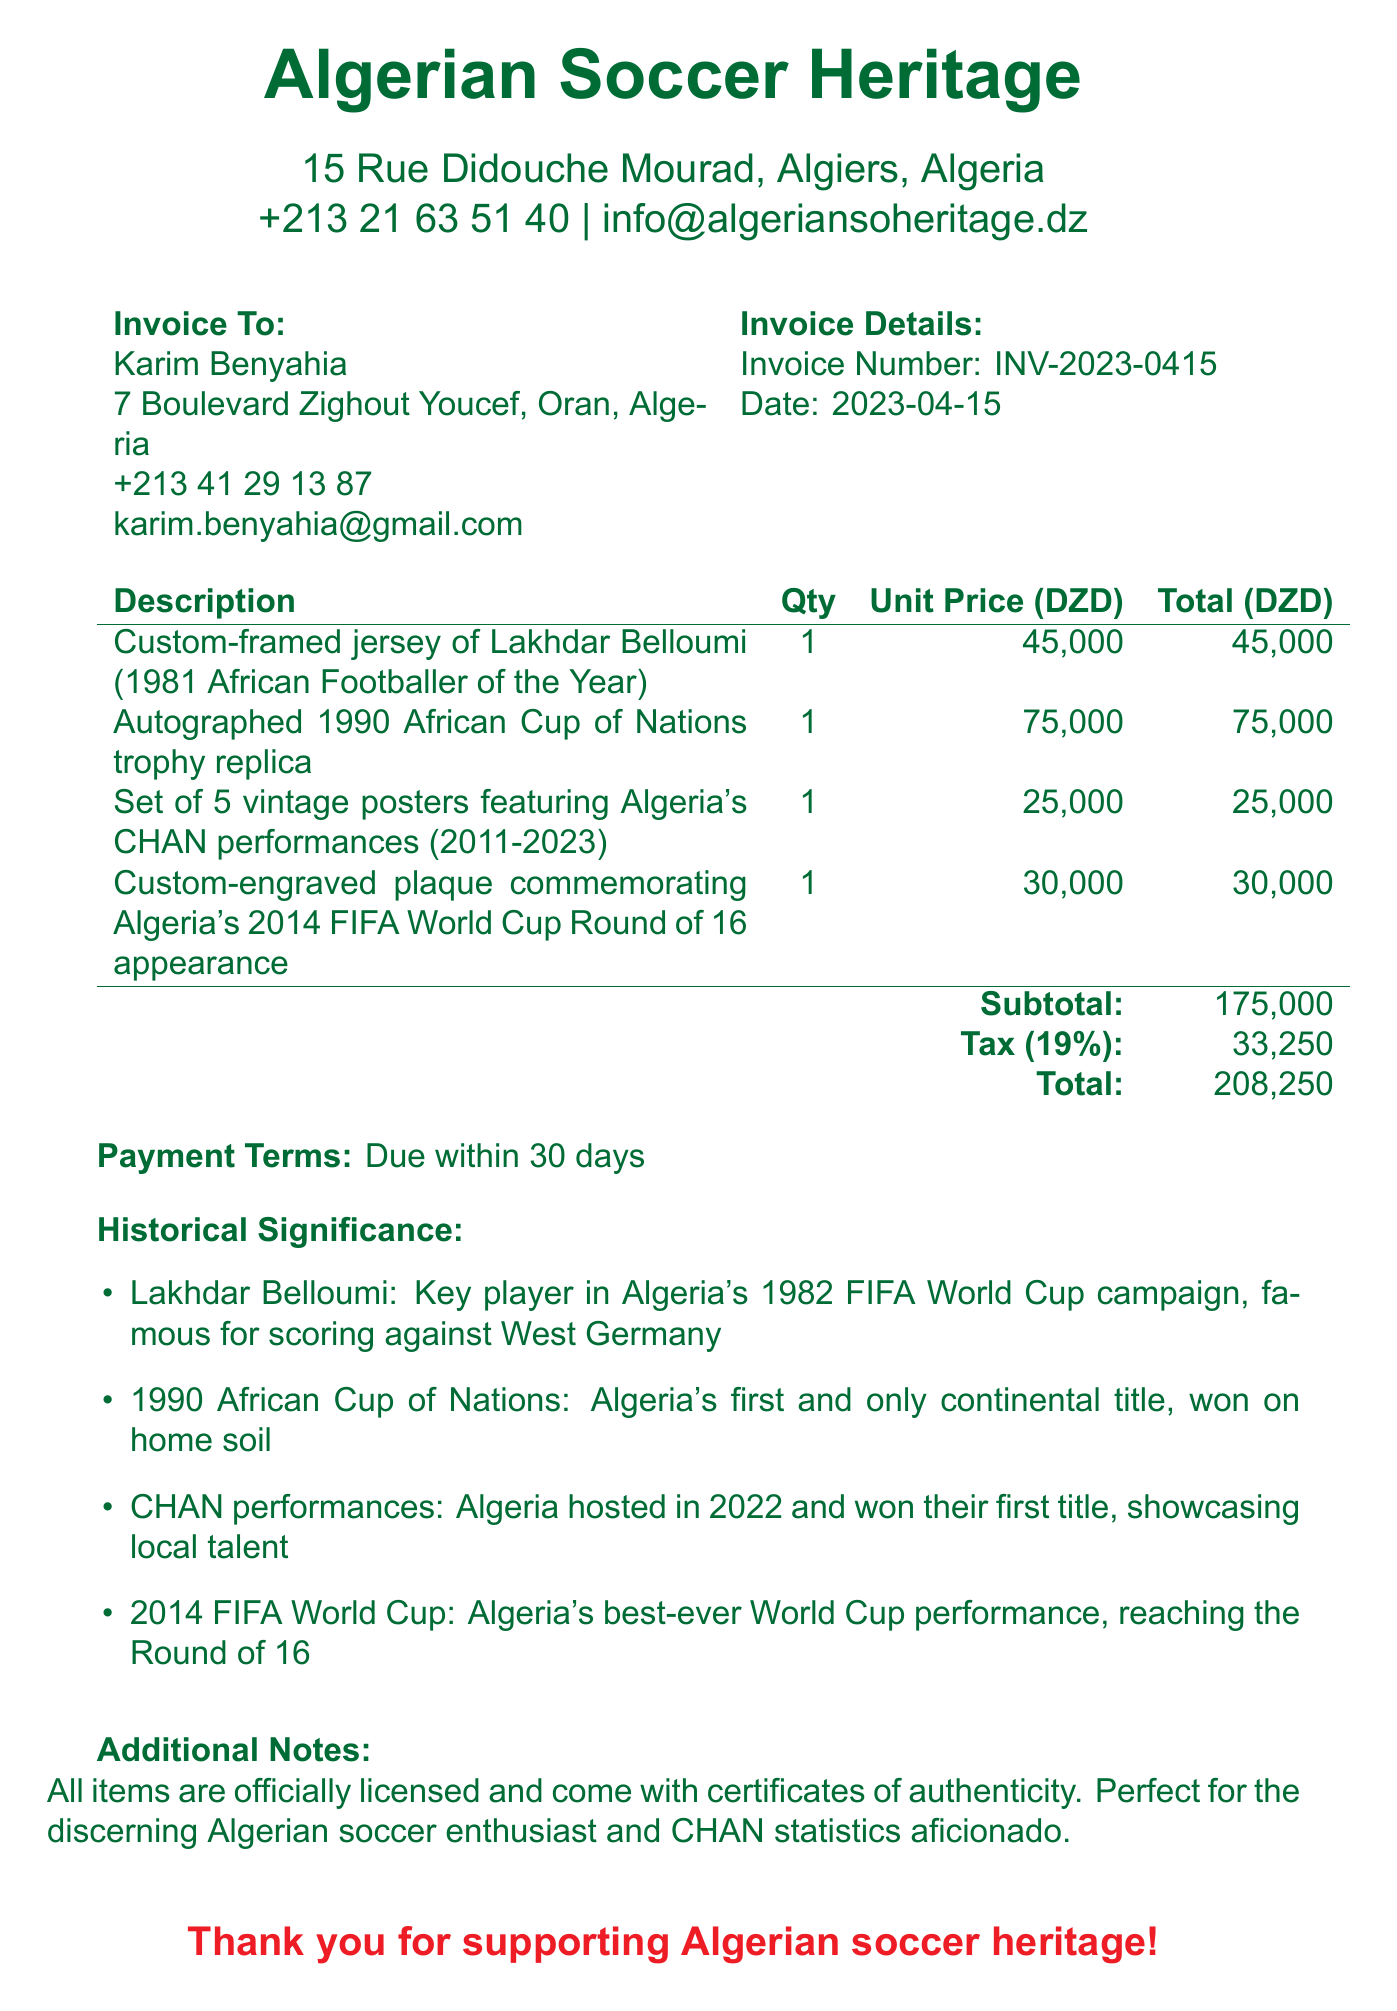What is the invoice number? The invoice number is specified in the details section of the document.
Answer: INV-2023-0415 Who is the buyer? The buyer's name is listed in the invoice details section.
Answer: Karim Benyahia What is the total amount due? The total amount is found at the bottom of the itemized list.
Answer: 208250 What is the tax rate applied? The tax rate is presented next to the tax amount in the invoice.
Answer: 19% Which item is associated with Lakhdar Belloumi? The item description for the jersey makes mention of Lakhdar Belloumi.
Answer: Custom-framed jersey of Lakhdar Belloumi (1981 African Footballer of the Year) What notable achievement does the 1990 African Cup of Nations represent? This information is found in the historical significance section of the document.
Answer: Algeria's first and only continental title What is the payment term? The payment term is stated clearly in the document.
Answer: Due within 30 days What types of memorabilia are included in the invoice? The items listed in the invoice provide various types of memorabilia.
Answer: Custom-framed jersey, trophy replica, vintage posters, engraved plaque What is the purpose of all items being officially licensed? The additional notes indicate the significance of the items for buyers.
Answer: Certificates of authenticity 